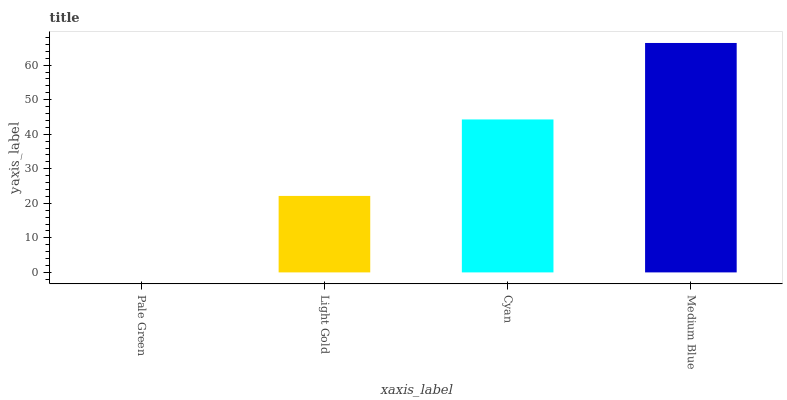Is Pale Green the minimum?
Answer yes or no. Yes. Is Medium Blue the maximum?
Answer yes or no. Yes. Is Light Gold the minimum?
Answer yes or no. No. Is Light Gold the maximum?
Answer yes or no. No. Is Light Gold greater than Pale Green?
Answer yes or no. Yes. Is Pale Green less than Light Gold?
Answer yes or no. Yes. Is Pale Green greater than Light Gold?
Answer yes or no. No. Is Light Gold less than Pale Green?
Answer yes or no. No. Is Cyan the high median?
Answer yes or no. Yes. Is Light Gold the low median?
Answer yes or no. Yes. Is Light Gold the high median?
Answer yes or no. No. Is Medium Blue the low median?
Answer yes or no. No. 